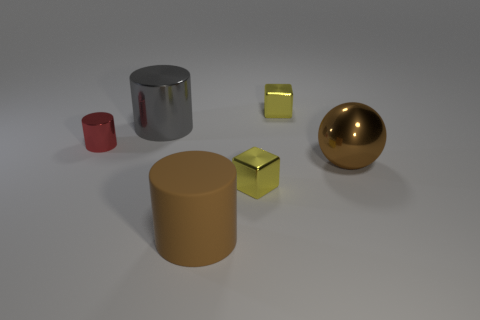Subtract all shiny cylinders. How many cylinders are left? 1 Add 1 large gray metallic cylinders. How many objects exist? 7 Subtract all brown cylinders. How many cylinders are left? 2 Subtract 1 cubes. How many cubes are left? 1 Subtract 0 cyan balls. How many objects are left? 6 Subtract all balls. How many objects are left? 5 Subtract all purple cylinders. Subtract all brown cubes. How many cylinders are left? 3 Subtract all blue cubes. How many brown cylinders are left? 1 Subtract all gray cylinders. Subtract all big matte cylinders. How many objects are left? 4 Add 6 brown matte things. How many brown matte things are left? 7 